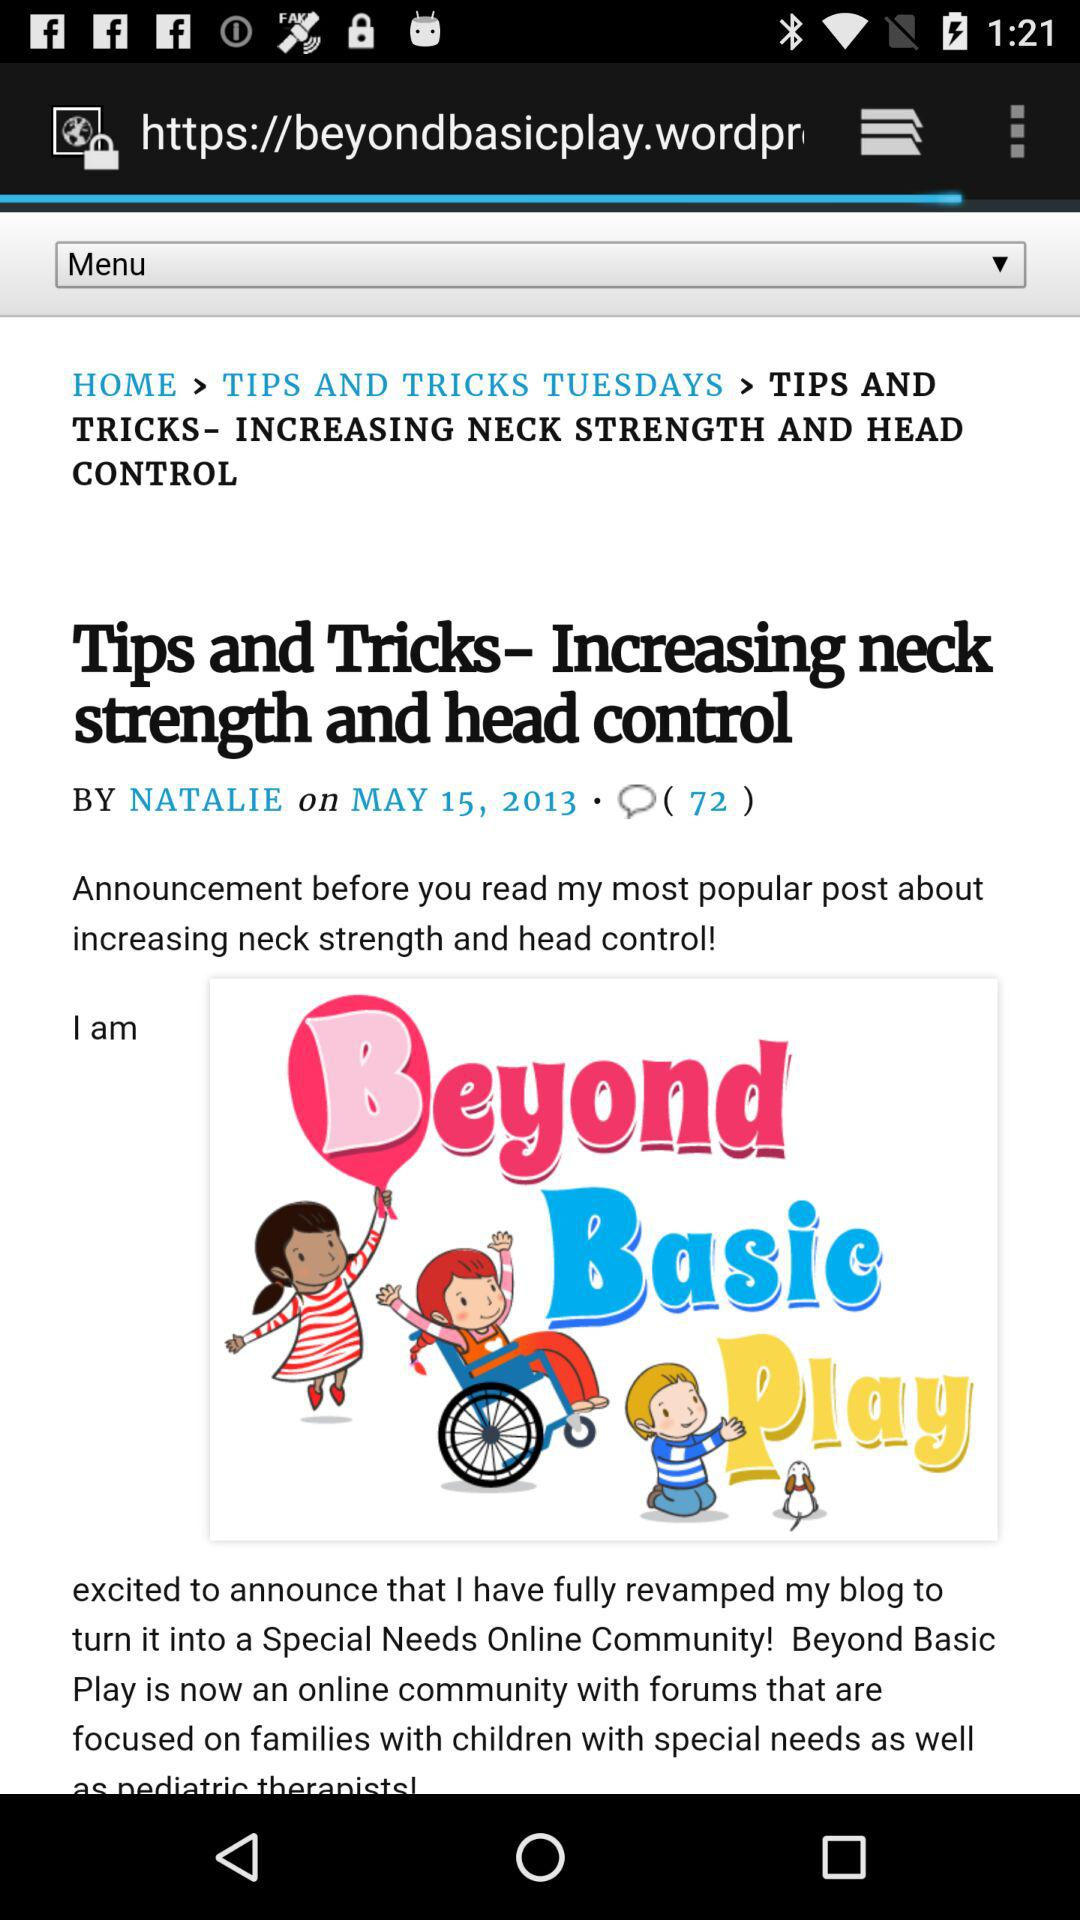When was the last comment made?
When the provided information is insufficient, respond with <no answer>. <no answer> 